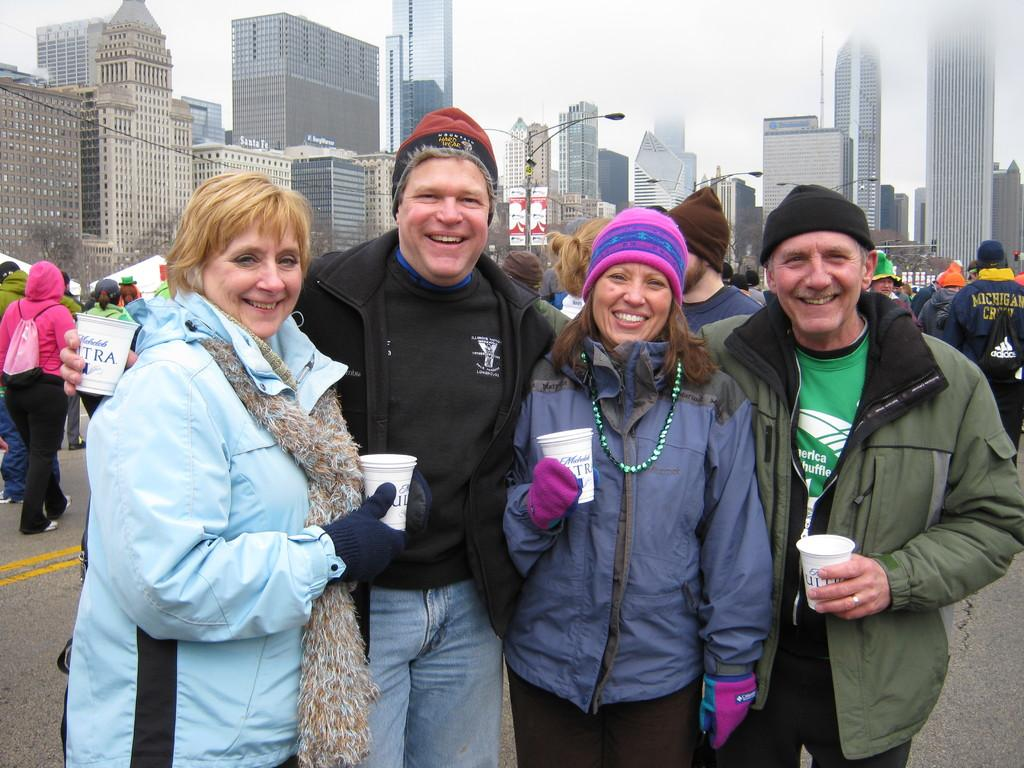What can be seen in the foreground of the image? There are people standing in the foreground of the image. What are some of the people holding in the image? Some people are holding posters in the image. What is visible in the background of the image? There are buildings and the sky visible in the background of the image. What type of basketball game is being played in the image? There is no basketball game present in the image. How many letters can be seen on the people's bodies in the image? There are no letters visible on people's bodies in the image. 